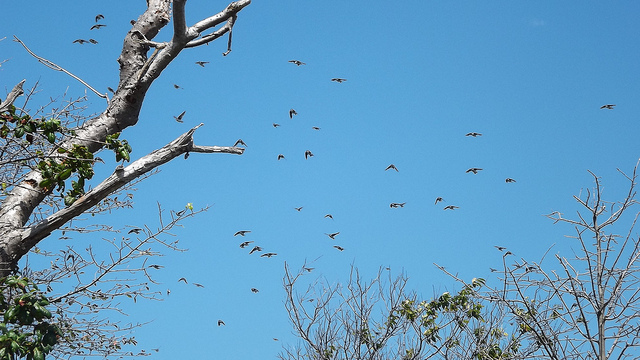<image>Are the branches bent up or down? I am not sure if the branches are bent up or down. Are the branches bent up or down? I am not sure if the branches are bent up or down. 